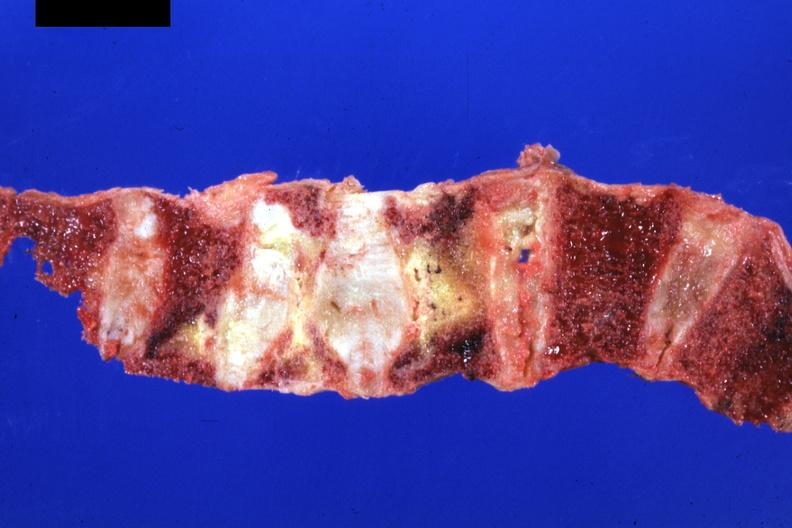does this image show good representation?
Answer the question using a single word or phrase. Yes 